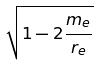Convert formula to latex. <formula><loc_0><loc_0><loc_500><loc_500>\sqrt { 1 - 2 \frac { m _ { e } } { r _ { e } } }</formula> 